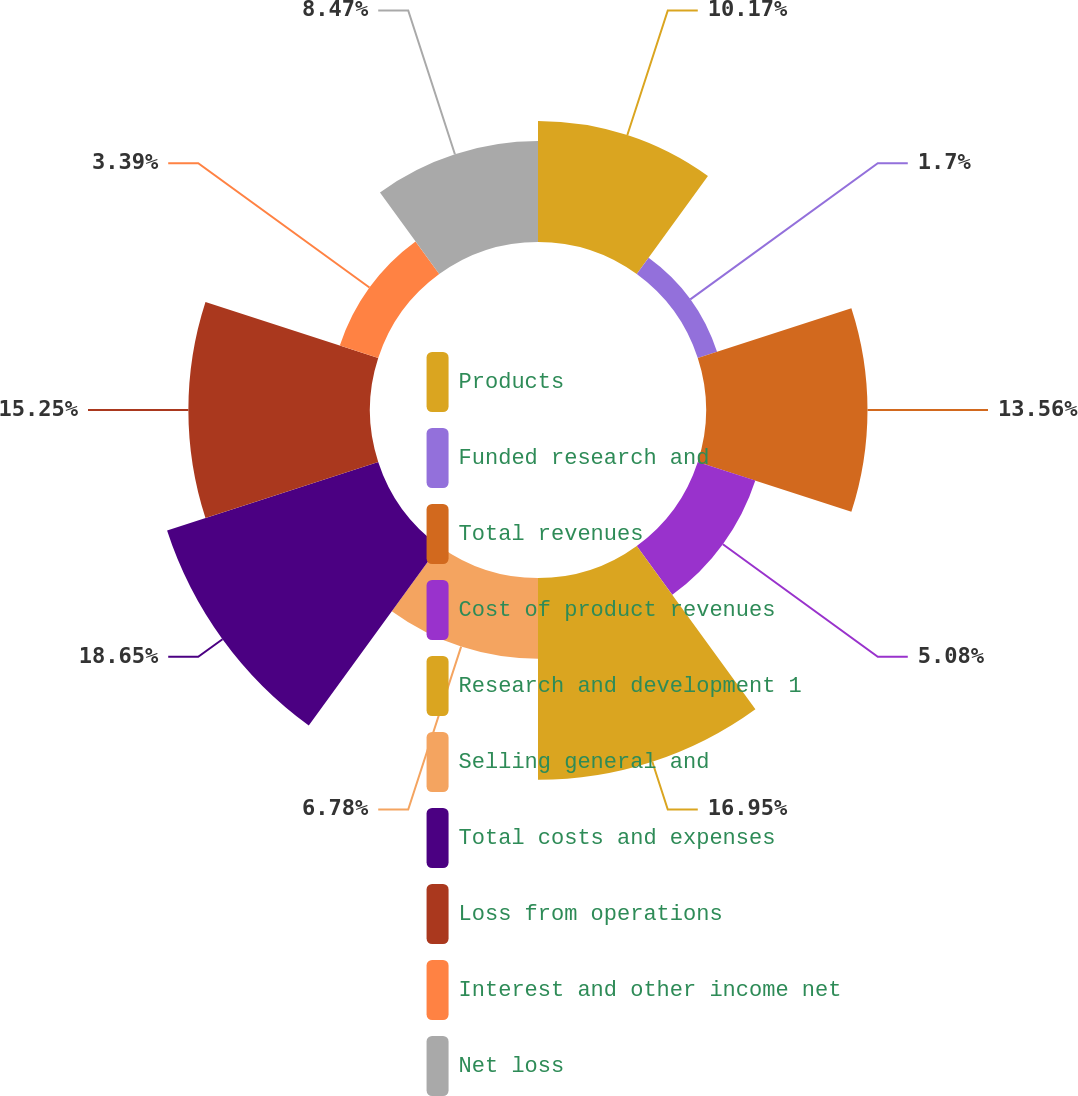<chart> <loc_0><loc_0><loc_500><loc_500><pie_chart><fcel>Products<fcel>Funded research and<fcel>Total revenues<fcel>Cost of product revenues<fcel>Research and development 1<fcel>Selling general and<fcel>Total costs and expenses<fcel>Loss from operations<fcel>Interest and other income net<fcel>Net loss<nl><fcel>10.17%<fcel>1.7%<fcel>13.56%<fcel>5.08%<fcel>16.95%<fcel>6.78%<fcel>18.64%<fcel>15.25%<fcel>3.39%<fcel>8.47%<nl></chart> 